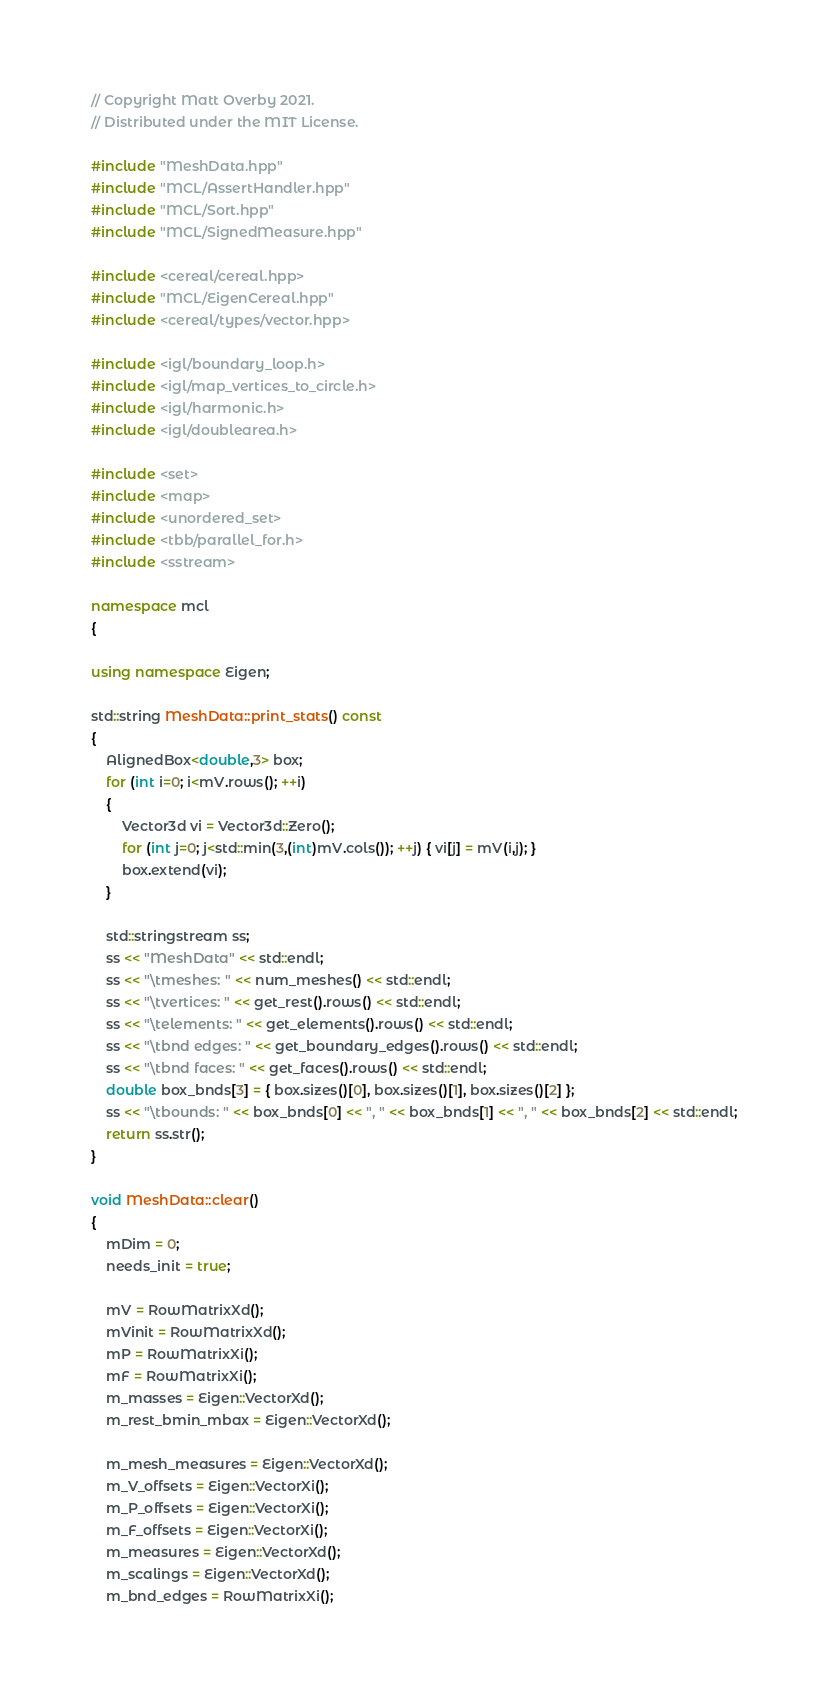Convert code to text. <code><loc_0><loc_0><loc_500><loc_500><_C++_>// Copyright Matt Overby 2021.
// Distributed under the MIT License.

#include "MeshData.hpp"
#include "MCL/AssertHandler.hpp"
#include "MCL/Sort.hpp"
#include "MCL/SignedMeasure.hpp"

#include <cereal/cereal.hpp>
#include "MCL/EigenCereal.hpp"
#include <cereal/types/vector.hpp>

#include <igl/boundary_loop.h>
#include <igl/map_vertices_to_circle.h>
#include <igl/harmonic.h>
#include <igl/doublearea.h>

#include <set>
#include <map>
#include <unordered_set>
#include <tbb/parallel_for.h>
#include <sstream>

namespace mcl
{

using namespace Eigen;

std::string MeshData::print_stats() const
{
	AlignedBox<double,3> box;
	for (int i=0; i<mV.rows(); ++i)
	{
		Vector3d vi = Vector3d::Zero();
		for (int j=0; j<std::min(3,(int)mV.cols()); ++j) { vi[j] = mV(i,j); }
		box.extend(vi);
	}

	std::stringstream ss;
	ss << "MeshData" << std::endl;
	ss << "\tmeshes: " << num_meshes() << std::endl;
	ss << "\tvertices: " << get_rest().rows() << std::endl;
	ss << "\telements: " << get_elements().rows() << std::endl;
	ss << "\tbnd edges: " << get_boundary_edges().rows() << std::endl;
	ss << "\tbnd faces: " << get_faces().rows() << std::endl;
	double box_bnds[3] = { box.sizes()[0], box.sizes()[1], box.sizes()[2] };
	ss << "\tbounds: " << box_bnds[0] << ", " << box_bnds[1] << ", " << box_bnds[2] << std::endl;
	return ss.str();
}

void MeshData::clear()
{
	mDim = 0;
	needs_init = true;

	mV = RowMatrixXd();
	mVinit = RowMatrixXd();
	mP = RowMatrixXi();
	mF = RowMatrixXi();
	m_masses = Eigen::VectorXd();
	m_rest_bmin_mbax = Eigen::VectorXd();

	m_mesh_measures = Eigen::VectorXd();
	m_V_offsets = Eigen::VectorXi();
	m_P_offsets = Eigen::VectorXi();
	m_F_offsets = Eigen::VectorXi();
	m_measures = Eigen::VectorXd();
	m_scalings = Eigen::VectorXd();
	m_bnd_edges = RowMatrixXi();</code> 